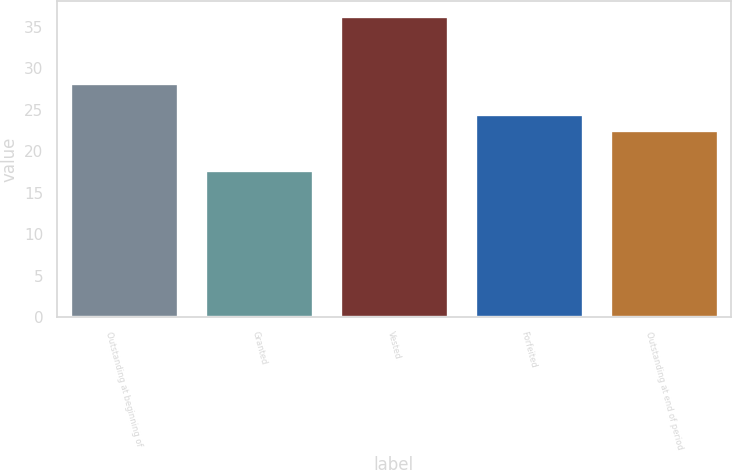Convert chart to OTSL. <chart><loc_0><loc_0><loc_500><loc_500><bar_chart><fcel>Outstanding at beginning of<fcel>Granted<fcel>Vested<fcel>Forfeited<fcel>Outstanding at end of period<nl><fcel>28.21<fcel>17.73<fcel>36.34<fcel>24.45<fcel>22.59<nl></chart> 